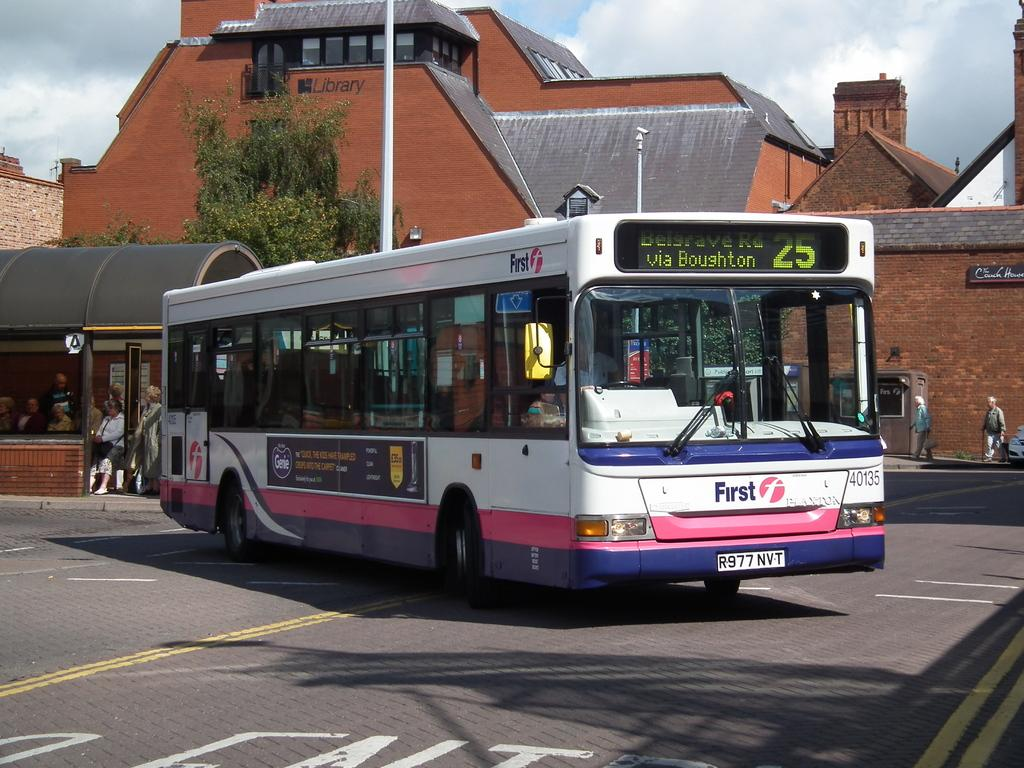<image>
Relay a brief, clear account of the picture shown. a city bus turning right and heading to via boughton. 